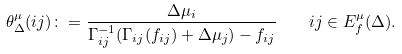<formula> <loc_0><loc_0><loc_500><loc_500>\theta ^ { \mu } _ { \Delta } ( i j ) \colon = \frac { \Delta \mu _ { i } } { \Gamma _ { i j } ^ { - 1 } ( \Gamma _ { i j } ( f _ { i j } ) + \Delta \mu _ { j } ) - f _ { i j } } \quad i j \in E _ { f } ^ { \mu } ( \Delta ) .</formula> 